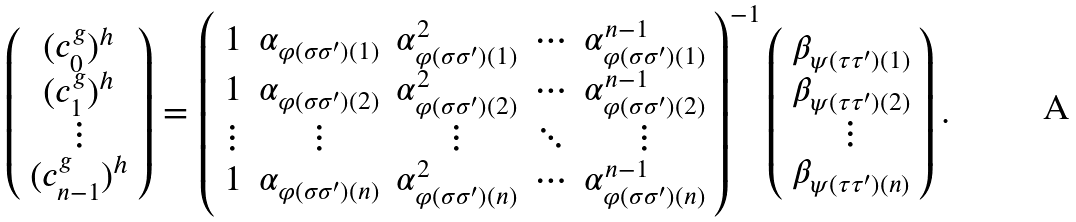<formula> <loc_0><loc_0><loc_500><loc_500>\left ( \begin{array} { c } ( c _ { 0 } ^ { g } ) ^ { h } \\ ( c _ { 1 } ^ { g } ) ^ { h } \\ \vdots \\ ( c _ { n - 1 } ^ { g } ) ^ { h } \end{array} \right ) = \left ( \begin{array} { c c c c c } 1 & \alpha _ { \varphi ( \sigma \sigma ^ { \prime } ) ( 1 ) } & \alpha _ { \varphi ( \sigma \sigma ^ { \prime } ) ( 1 ) } ^ { 2 } & \cdots & \alpha _ { \varphi ( \sigma \sigma ^ { \prime } ) ( 1 ) } ^ { n - 1 } \\ 1 & \alpha _ { \varphi ( \sigma \sigma ^ { \prime } ) ( 2 ) } & \alpha _ { \varphi ( \sigma \sigma ^ { \prime } ) ( 2 ) } ^ { 2 } & \cdots & \alpha _ { \varphi ( \sigma \sigma ^ { \prime } ) ( 2 ) } ^ { n - 1 } \\ \vdots & \vdots & \vdots & \ddots & \vdots \\ 1 & \alpha _ { \varphi ( \sigma \sigma ^ { \prime } ) ( n ) } & \alpha _ { \varphi ( \sigma \sigma ^ { \prime } ) ( n ) } ^ { 2 } & \cdots & \alpha _ { \varphi ( \sigma \sigma ^ { \prime } ) ( n ) } ^ { n - 1 } \end{array} \right ) ^ { - 1 } \left ( \begin{array} { c } \beta _ { \psi ( \tau \tau ^ { \prime } ) ( 1 ) } \\ \beta _ { \psi ( \tau \tau ^ { \prime } ) ( 2 ) } \\ \vdots \\ \beta _ { \psi ( \tau \tau ^ { \prime } ) ( n ) } \end{array} \right ) .</formula> 